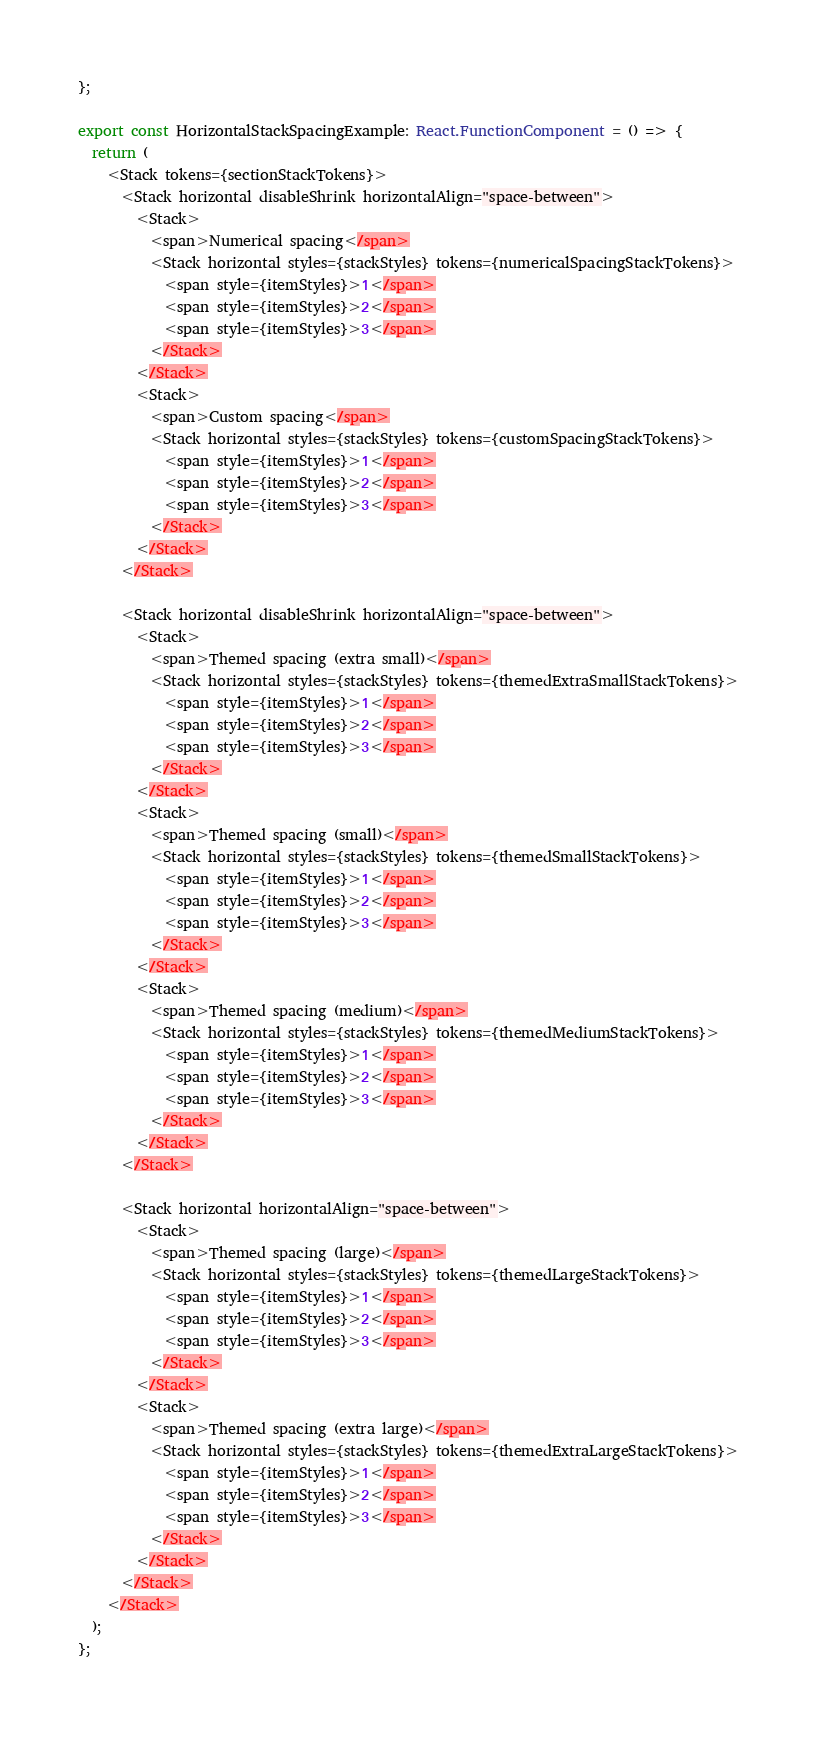Convert code to text. <code><loc_0><loc_0><loc_500><loc_500><_TypeScript_>};

export const HorizontalStackSpacingExample: React.FunctionComponent = () => {
  return (
    <Stack tokens={sectionStackTokens}>
      <Stack horizontal disableShrink horizontalAlign="space-between">
        <Stack>
          <span>Numerical spacing</span>
          <Stack horizontal styles={stackStyles} tokens={numericalSpacingStackTokens}>
            <span style={itemStyles}>1</span>
            <span style={itemStyles}>2</span>
            <span style={itemStyles}>3</span>
          </Stack>
        </Stack>
        <Stack>
          <span>Custom spacing</span>
          <Stack horizontal styles={stackStyles} tokens={customSpacingStackTokens}>
            <span style={itemStyles}>1</span>
            <span style={itemStyles}>2</span>
            <span style={itemStyles}>3</span>
          </Stack>
        </Stack>
      </Stack>

      <Stack horizontal disableShrink horizontalAlign="space-between">
        <Stack>
          <span>Themed spacing (extra small)</span>
          <Stack horizontal styles={stackStyles} tokens={themedExtraSmallStackTokens}>
            <span style={itemStyles}>1</span>
            <span style={itemStyles}>2</span>
            <span style={itemStyles}>3</span>
          </Stack>
        </Stack>
        <Stack>
          <span>Themed spacing (small)</span>
          <Stack horizontal styles={stackStyles} tokens={themedSmallStackTokens}>
            <span style={itemStyles}>1</span>
            <span style={itemStyles}>2</span>
            <span style={itemStyles}>3</span>
          </Stack>
        </Stack>
        <Stack>
          <span>Themed spacing (medium)</span>
          <Stack horizontal styles={stackStyles} tokens={themedMediumStackTokens}>
            <span style={itemStyles}>1</span>
            <span style={itemStyles}>2</span>
            <span style={itemStyles}>3</span>
          </Stack>
        </Stack>
      </Stack>

      <Stack horizontal horizontalAlign="space-between">
        <Stack>
          <span>Themed spacing (large)</span>
          <Stack horizontal styles={stackStyles} tokens={themedLargeStackTokens}>
            <span style={itemStyles}>1</span>
            <span style={itemStyles}>2</span>
            <span style={itemStyles}>3</span>
          </Stack>
        </Stack>
        <Stack>
          <span>Themed spacing (extra large)</span>
          <Stack horizontal styles={stackStyles} tokens={themedExtraLargeStackTokens}>
            <span style={itemStyles}>1</span>
            <span style={itemStyles}>2</span>
            <span style={itemStyles}>3</span>
          </Stack>
        </Stack>
      </Stack>
    </Stack>
  );
};
</code> 